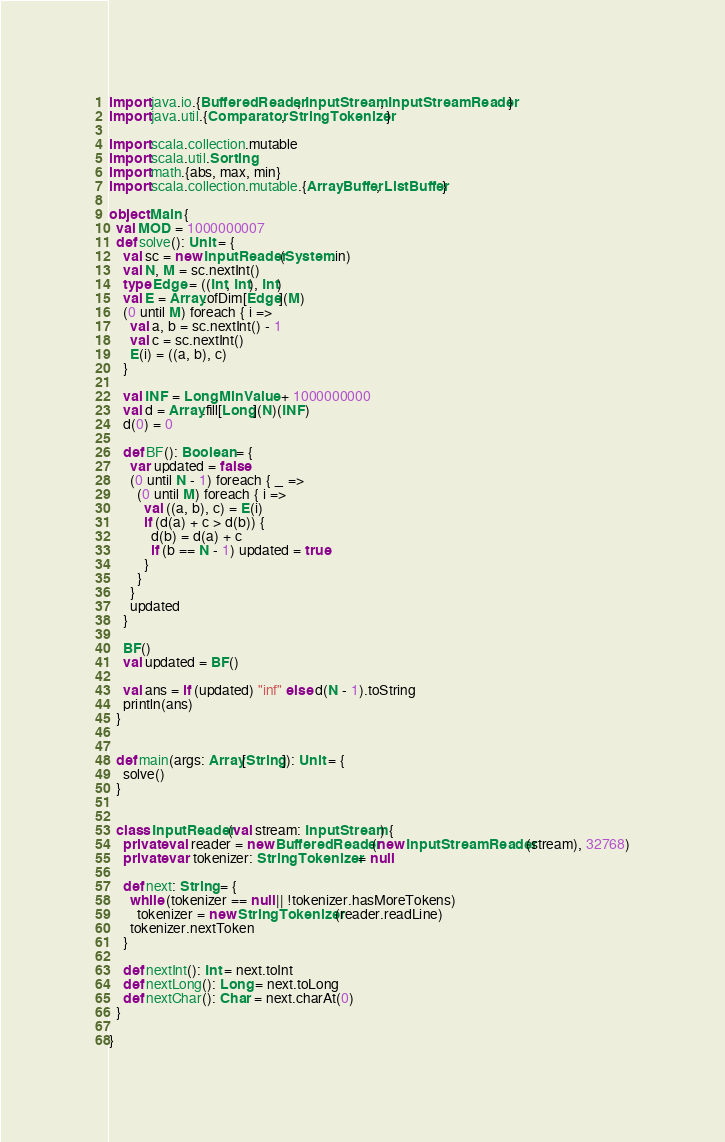Convert code to text. <code><loc_0><loc_0><loc_500><loc_500><_Scala_>import java.io.{BufferedReader, InputStream, InputStreamReader}
import java.util.{Comparator, StringTokenizer}

import scala.collection.mutable
import scala.util.Sorting
import math.{abs, max, min}
import scala.collection.mutable.{ArrayBuffer, ListBuffer}

object Main {
  val MOD = 1000000007
  def solve(): Unit = {
    val sc = new InputReader(System.in)
    val N, M = sc.nextInt()
    type Edge = ((Int, Int), Int)
    val E = Array.ofDim[Edge](M)
    (0 until M) foreach { i =>
      val a, b = sc.nextInt() - 1
      val c = sc.nextInt()
      E(i) = ((a, b), c)
    }

    val INF = Long.MinValue + 1000000000
    val d = Array.fill[Long](N)(INF)
    d(0) = 0

    def BF(): Boolean = {
      var updated = false
      (0 until N - 1) foreach { _ =>
        (0 until M) foreach { i =>
          val ((a, b), c) = E(i)
          if (d(a) + c > d(b)) {
            d(b) = d(a) + c
            if (b == N - 1) updated = true
          }
        }
      }
      updated
    }

    BF()
    val updated = BF()

    val ans = if (updated) "inf" else d(N - 1).toString
    println(ans)
  }


  def main(args: Array[String]): Unit = {
    solve()
  }


  class InputReader(val stream: InputStream) {
    private val reader = new BufferedReader(new InputStreamReader(stream), 32768)
    private var tokenizer: StringTokenizer = null

    def next: String = {
      while (tokenizer == null || !tokenizer.hasMoreTokens)
        tokenizer = new StringTokenizer(reader.readLine)
      tokenizer.nextToken
    }

    def nextInt(): Int = next.toInt
    def nextLong(): Long = next.toLong
    def nextChar(): Char = next.charAt(0)
  }

}
</code> 